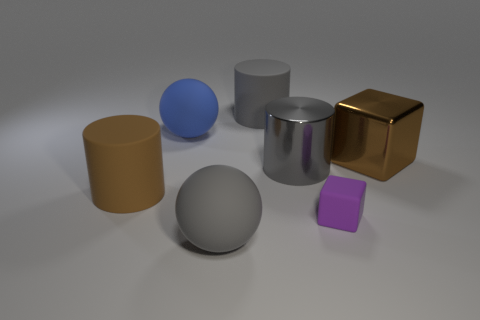Is there anything else that is the same shape as the gray shiny object?
Keep it short and to the point. Yes. There is another object that is the same shape as the blue rubber object; what color is it?
Provide a succinct answer. Gray. What is the color of the cube that is made of the same material as the large blue thing?
Offer a terse response. Purple. Is the number of big cylinders that are behind the big blue matte sphere the same as the number of cyan balls?
Offer a terse response. No. Does the gray rubber thing that is behind the brown metallic block have the same size as the small matte cube?
Keep it short and to the point. No. There is a cube that is the same size as the gray matte ball; what color is it?
Make the answer very short. Brown. Is there a big gray object that is on the right side of the matte sphere that is in front of the rubber thing that is right of the gray shiny cylinder?
Offer a terse response. Yes. What is the large thing that is in front of the purple cube made of?
Provide a short and direct response. Rubber. There is a big brown rubber thing; is its shape the same as the big brown thing on the right side of the large brown rubber thing?
Give a very brief answer. No. Are there the same number of big gray metal cylinders on the right side of the purple thing and blocks in front of the large brown rubber cylinder?
Provide a short and direct response. No. 